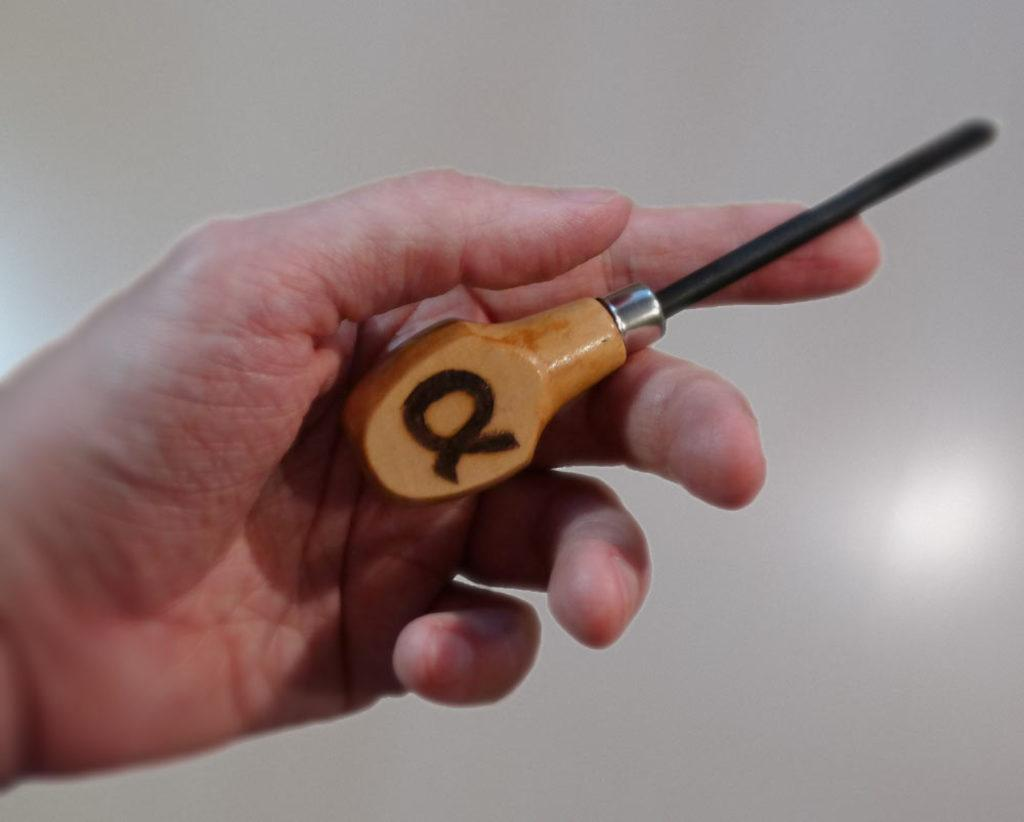What part of a person can be seen in the image? There is a hand of a person in the image. What is the hand holding? The hand is holding an object. What can be seen on the object being held? There is a sign on the object. What color is the background of the image? The background of the image is white. How many bears can be seen in the image? There are no bears present in the image. Is the image set during the night? The image does not provide any information about the time of day, but the white background suggests it might be during the day. 